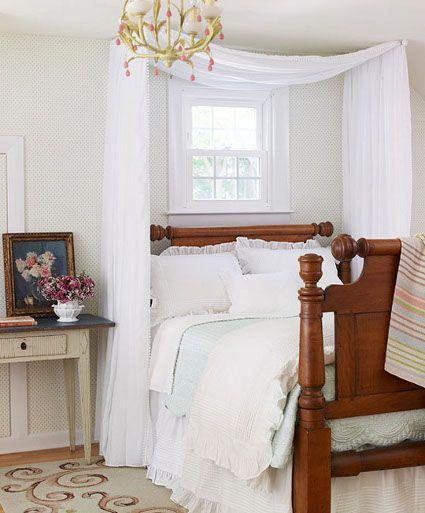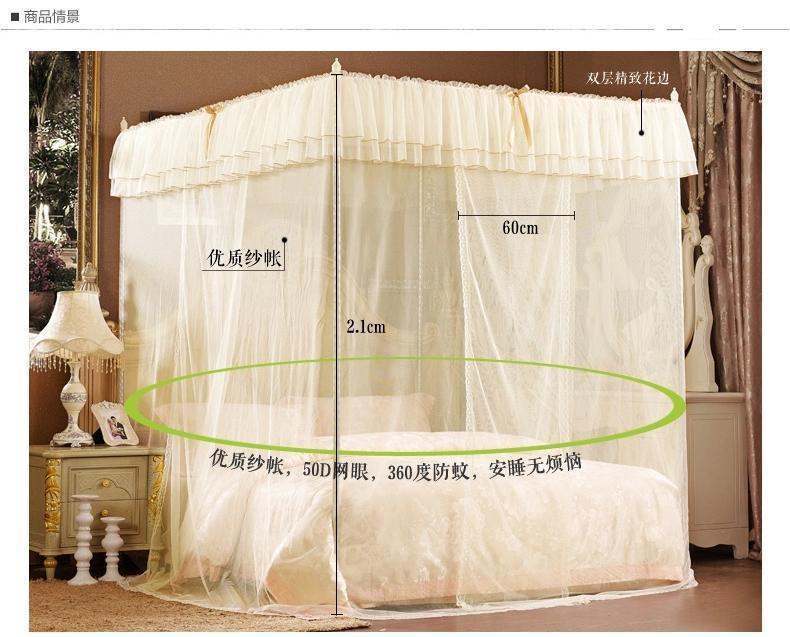The first image is the image on the left, the second image is the image on the right. Analyze the images presented: Is the assertion "At least one image shows a bed with a wooden headboard." valid? Answer yes or no. Yes. 